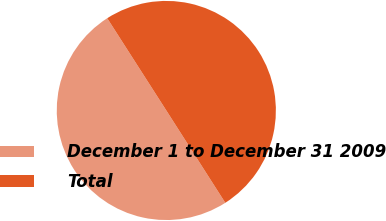<chart> <loc_0><loc_0><loc_500><loc_500><pie_chart><fcel>December 1 to December 31 2009<fcel>Total<nl><fcel>49.98%<fcel>50.02%<nl></chart> 